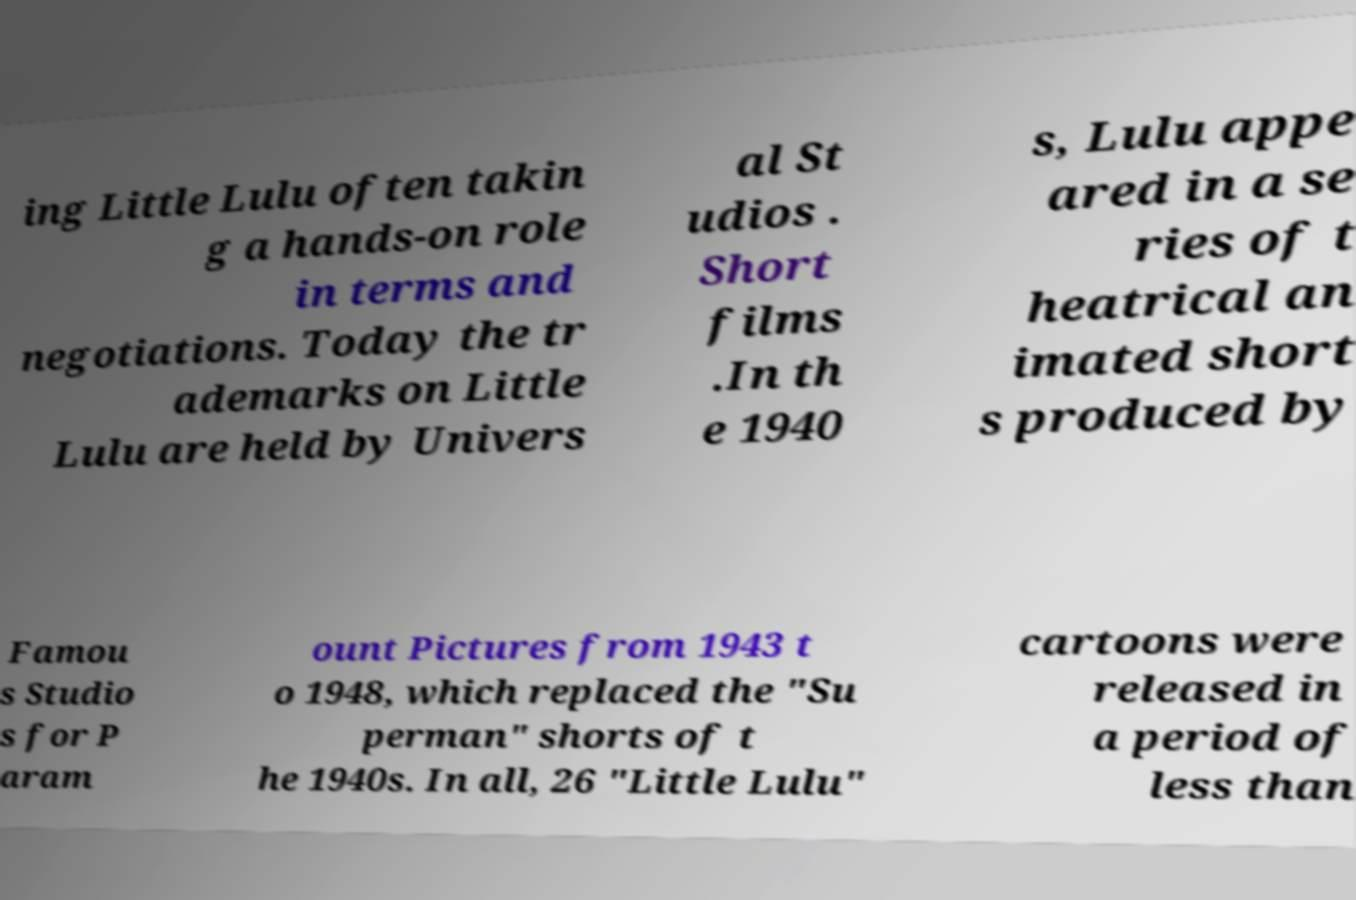There's text embedded in this image that I need extracted. Can you transcribe it verbatim? ing Little Lulu often takin g a hands-on role in terms and negotiations. Today the tr ademarks on Little Lulu are held by Univers al St udios . Short films .In th e 1940 s, Lulu appe ared in a se ries of t heatrical an imated short s produced by Famou s Studio s for P aram ount Pictures from 1943 t o 1948, which replaced the "Su perman" shorts of t he 1940s. In all, 26 "Little Lulu" cartoons were released in a period of less than 